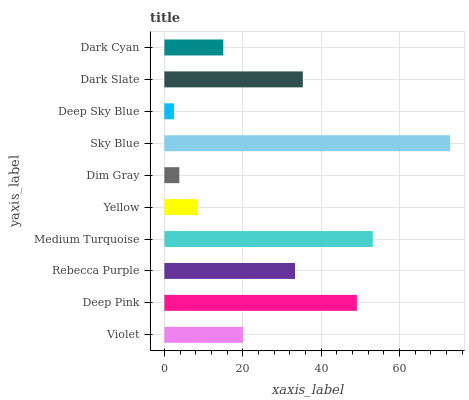Is Deep Sky Blue the minimum?
Answer yes or no. Yes. Is Sky Blue the maximum?
Answer yes or no. Yes. Is Deep Pink the minimum?
Answer yes or no. No. Is Deep Pink the maximum?
Answer yes or no. No. Is Deep Pink greater than Violet?
Answer yes or no. Yes. Is Violet less than Deep Pink?
Answer yes or no. Yes. Is Violet greater than Deep Pink?
Answer yes or no. No. Is Deep Pink less than Violet?
Answer yes or no. No. Is Rebecca Purple the high median?
Answer yes or no. Yes. Is Violet the low median?
Answer yes or no. Yes. Is Deep Sky Blue the high median?
Answer yes or no. No. Is Yellow the low median?
Answer yes or no. No. 